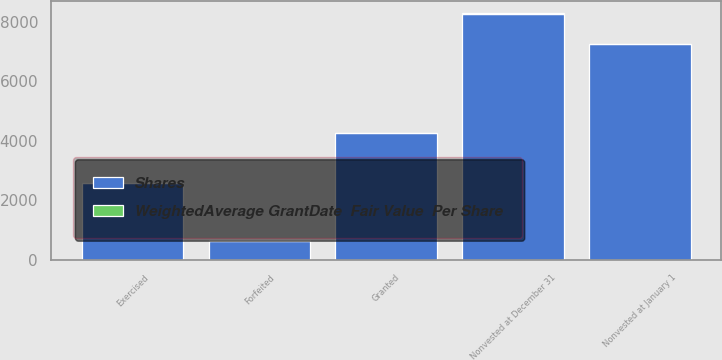Convert chart. <chart><loc_0><loc_0><loc_500><loc_500><stacked_bar_chart><ecel><fcel>Nonvested at January 1<fcel>Granted<fcel>Exercised<fcel>Forfeited<fcel>Nonvested at December 31<nl><fcel>Shares<fcel>7253<fcel>4250<fcel>2580<fcel>642<fcel>8281<nl><fcel>WeightedAverage GrantDate  Fair Value  Per Share<fcel>17.98<fcel>19.11<fcel>16.86<fcel>18.64<fcel>18.88<nl></chart> 